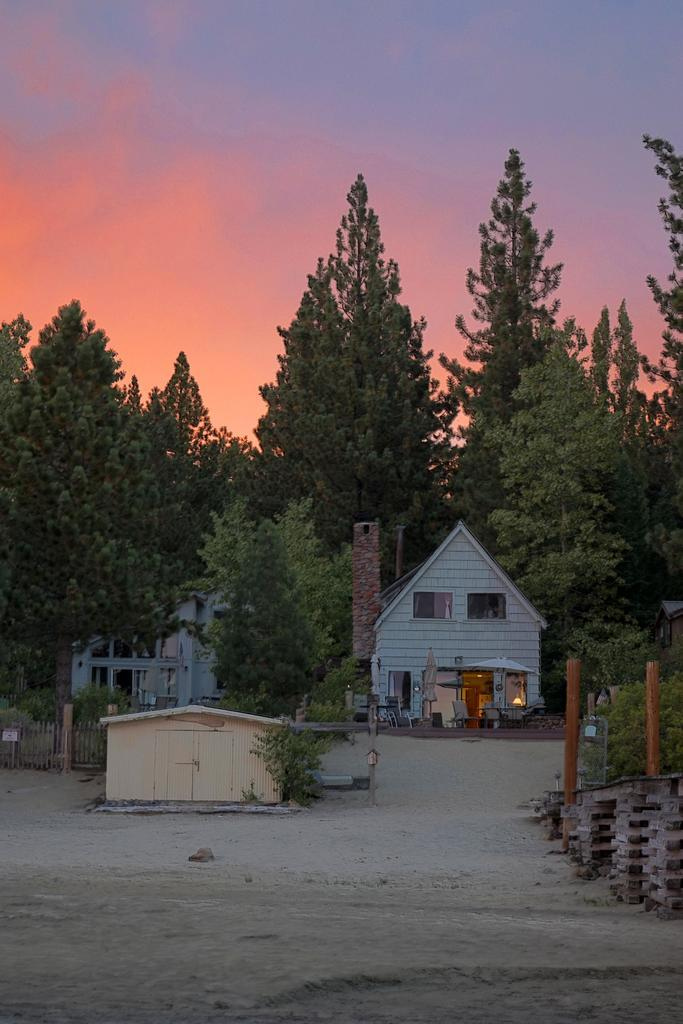What type of structures can be seen in the image? There are houses in the image. What type of vegetation is visible in the image? There are trees visible in the image. What type of terrain is visible in the image? There is land visible in the image. What type of mint is growing on the roofs of the houses in the image? There is no mint visible in the image, and mint is not typically found growing on the roofs of houses. 